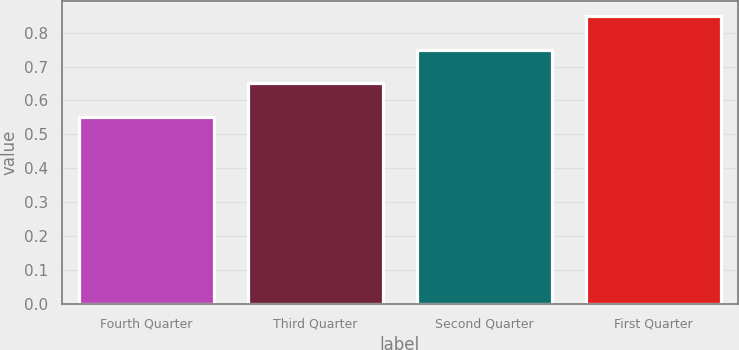Convert chart. <chart><loc_0><loc_0><loc_500><loc_500><bar_chart><fcel>Fourth Quarter<fcel>Third Quarter<fcel>Second Quarter<fcel>First Quarter<nl><fcel>0.55<fcel>0.65<fcel>0.75<fcel>0.85<nl></chart> 